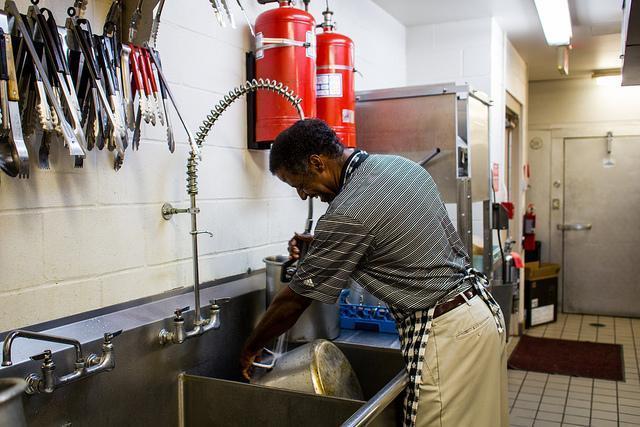How many sinks are there?
Give a very brief answer. 1. 